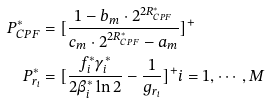<formula> <loc_0><loc_0><loc_500><loc_500>P ^ { * } _ { C P F } & = [ \frac { 1 - b _ { m } \cdot 2 ^ { 2 R ^ { * } _ { C P F } } } { c _ { m } \cdot 2 ^ { 2 R ^ { * } _ { C P F } } - a _ { m } } ] ^ { + } \\ P ^ { * } _ { r _ { i } } & = [ \frac { f _ { i } ^ { * } \gamma _ { i } ^ { * } } { 2 \beta _ { i } ^ { * } \ln 2 } - \frac { 1 } { g _ { r _ { i } } } ] ^ { + } i = 1 , \cdots , M</formula> 